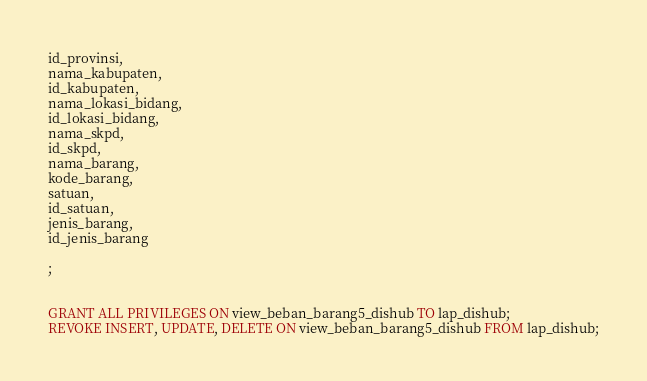Convert code to text. <code><loc_0><loc_0><loc_500><loc_500><_SQL_>id_provinsi,
nama_kabupaten,
id_kabupaten,
nama_lokasi_bidang,
id_lokasi_bidang,
nama_skpd,
id_skpd,
nama_barang,
kode_barang,
satuan,
id_satuan,
jenis_barang,
id_jenis_barang

;


GRANT ALL PRIVILEGES ON view_beban_barang5_dishub TO lap_dishub;
REVOKE INSERT, UPDATE, DELETE ON view_beban_barang5_dishub FROM lap_dishub;
</code> 